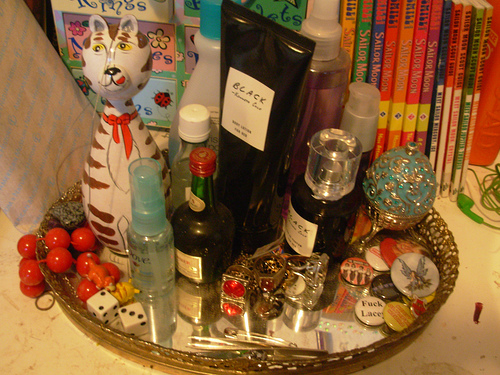<image>
Can you confirm if the plate is under the bottle? Yes. The plate is positioned underneath the bottle, with the bottle above it in the vertical space. 